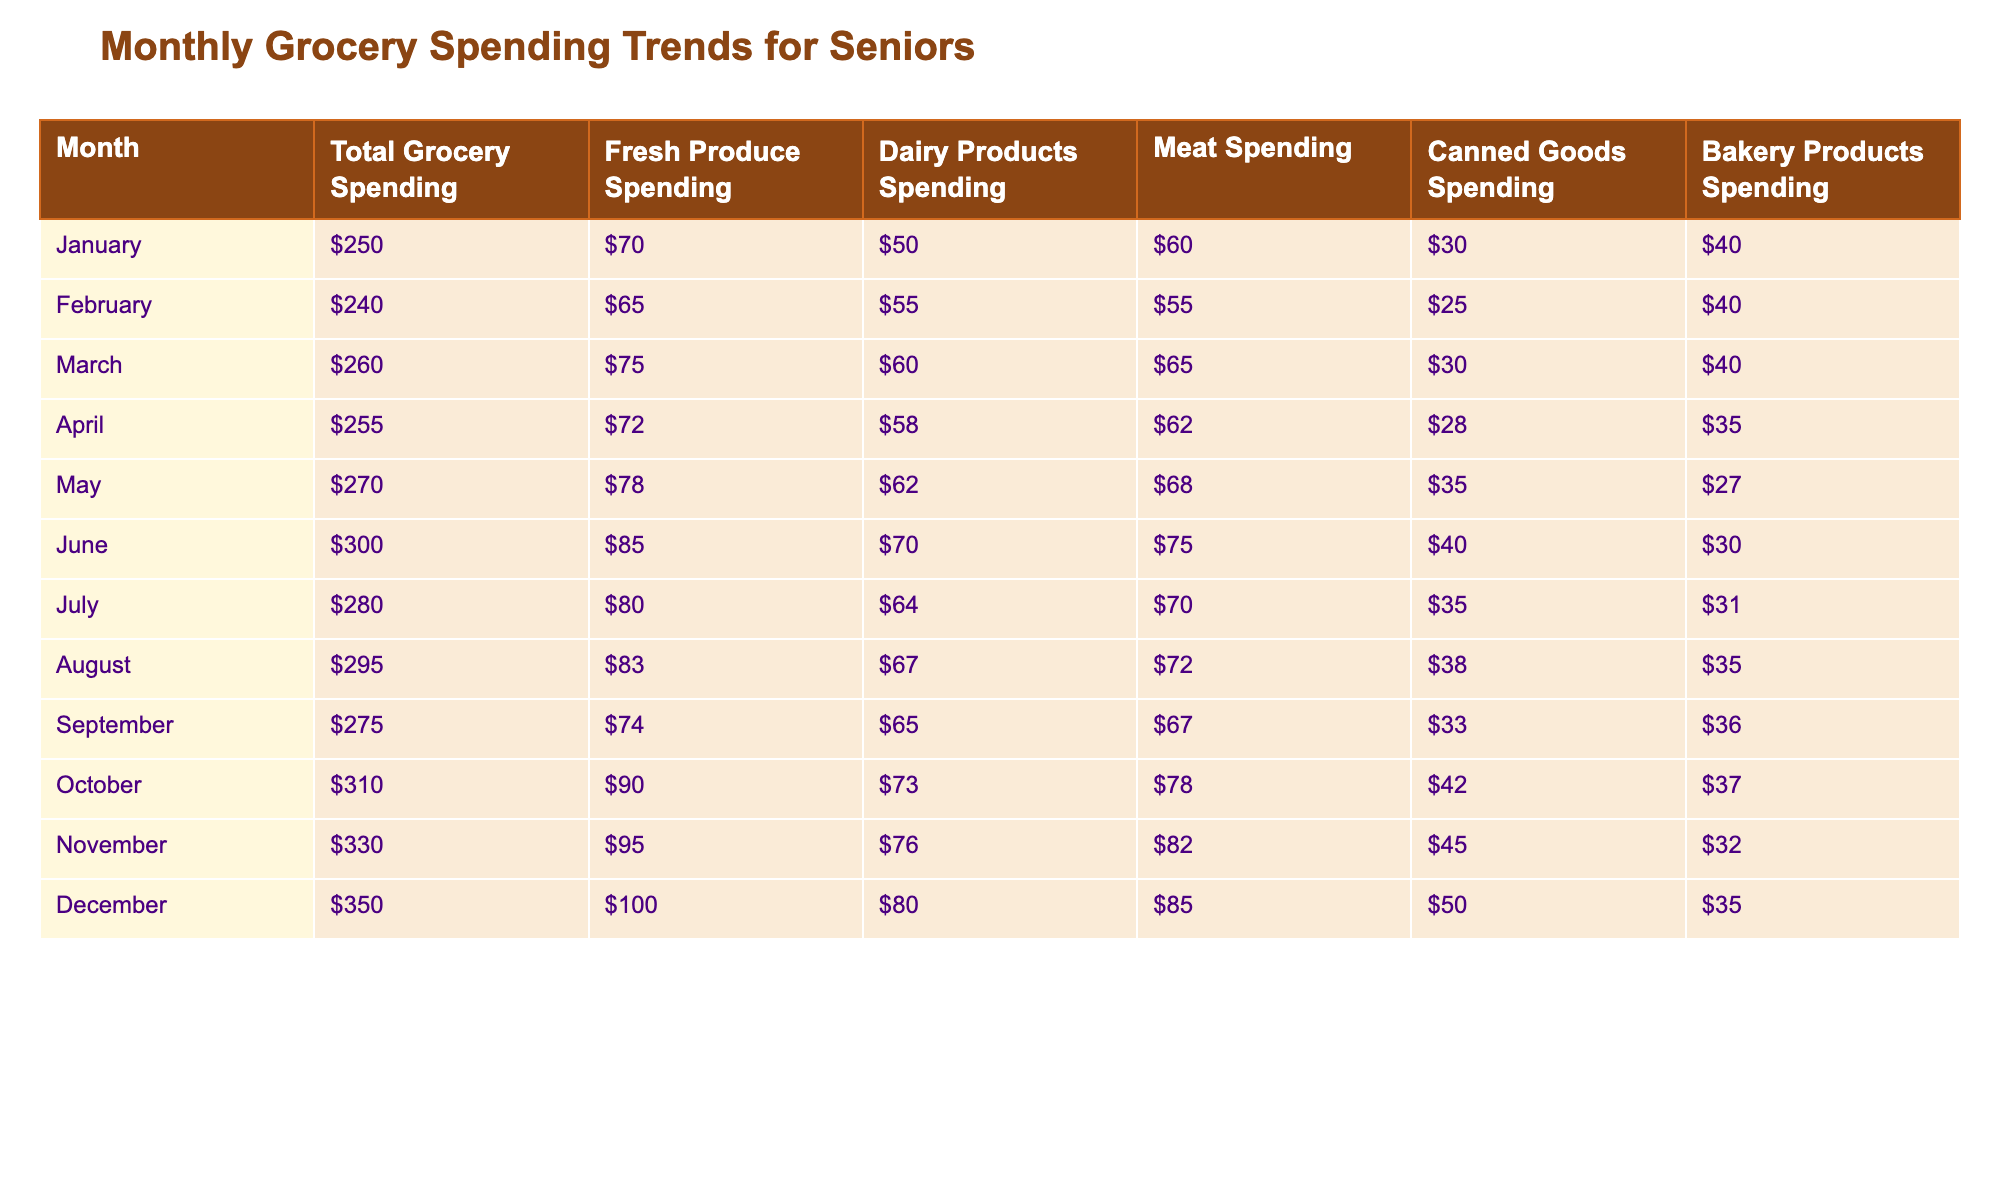What was the highest total grocery spending in a month? By examining the "Total Grocery Spending" row, December shows the highest amount of $350, which is greater than all other months.
Answer: $350 Which month had the lowest spending on fresh produce? Looking at the "Fresh Produce Spending" column, February has the lowest value of $65 among all the months listed.
Answer: $65 What is the average meat spending across the whole year? To find the average, sum the meat spending for each month: (60 + 55 + 65 + 62 + 68 + 75 + 70 + 72 + 67 + 78 + 82 + 85) = 818. There are 12 months, so the average is 818/12 = 68.17.
Answer: $68.17 Did the total grocery spending ever exceed $300? By scanning the "Total Grocery Spending" row, I can see that the spending did exceed $300 in October ($310), November ($330), and December ($350). Thus, the answer is yes.
Answer: Yes Which month had the highest spending on dairy products? In the "Dairy Products Spending" column, December shows the highest amount of $80, surpassing all other months.
Answer: $80 How much more was spent on canned goods in December compared to January? In January, canned goods spending was $30, and in December, it was $50. The difference is $50 - $30 = $20.
Answer: $20 In how many months did total grocery spending exceed $250? By checking the "Total Grocery Spending" row, I find that spending exceeds $250 in March, May, June, July, August, October, November, and December. That makes a total of 8 months.
Answer: 8 What is the difference between the highest and lowest spending on bakery products for the year? Reviewing the "Bakery Products Spending" column, the highest is in June at $30, and the lowest is in May at $27. The difference is $35 - $27 = $5.
Answer: $5 Which month saw the most increase in total spending compared to the previous month? Looking at the "Total Grocery Spending" values month-over-month, June shows an increase of $300 - $270 = $30 from May, which is the highest increase.
Answer: June Was the spending on meat higher in April than in January? By comparing the values in the "Meat Spending" column, January spent $60 on meat, and April spent $62. Since $62 > $60, the answer is yes.
Answer: Yes 